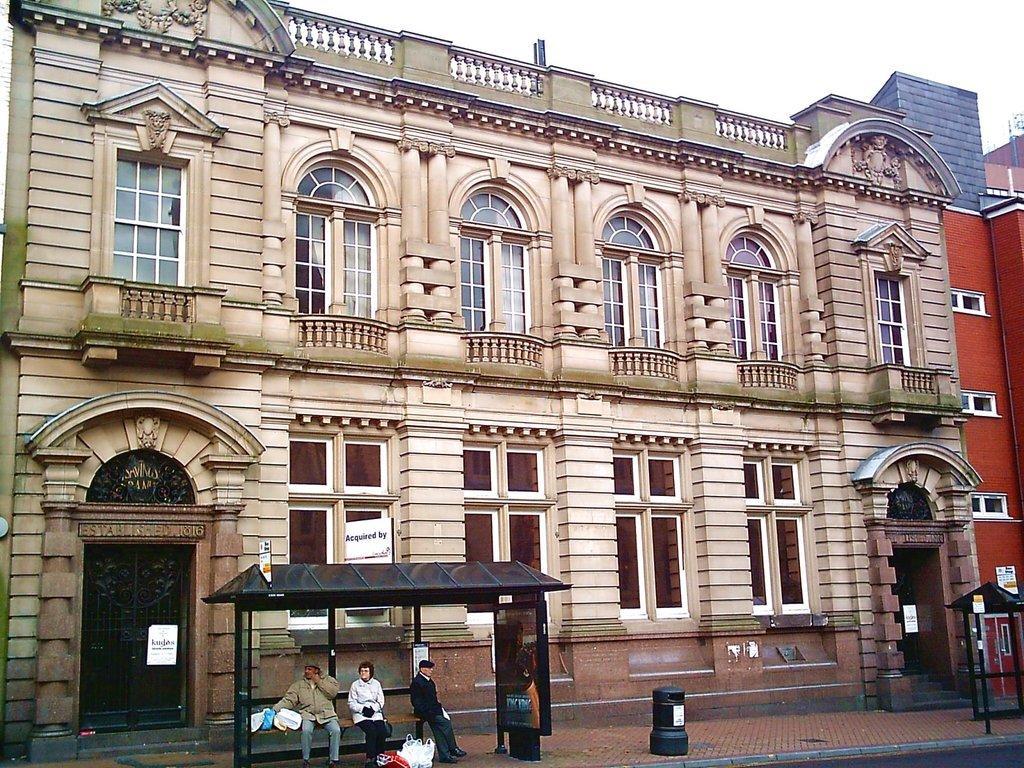Can you describe this image briefly? This picture might be taken from outside of the building. In this image, we can see three people are sitting on the bench inside the bus stop. In the background, we can see a building, door, glass window. On the top, we can see a sky, at the bottom there is a footpath and a road. 